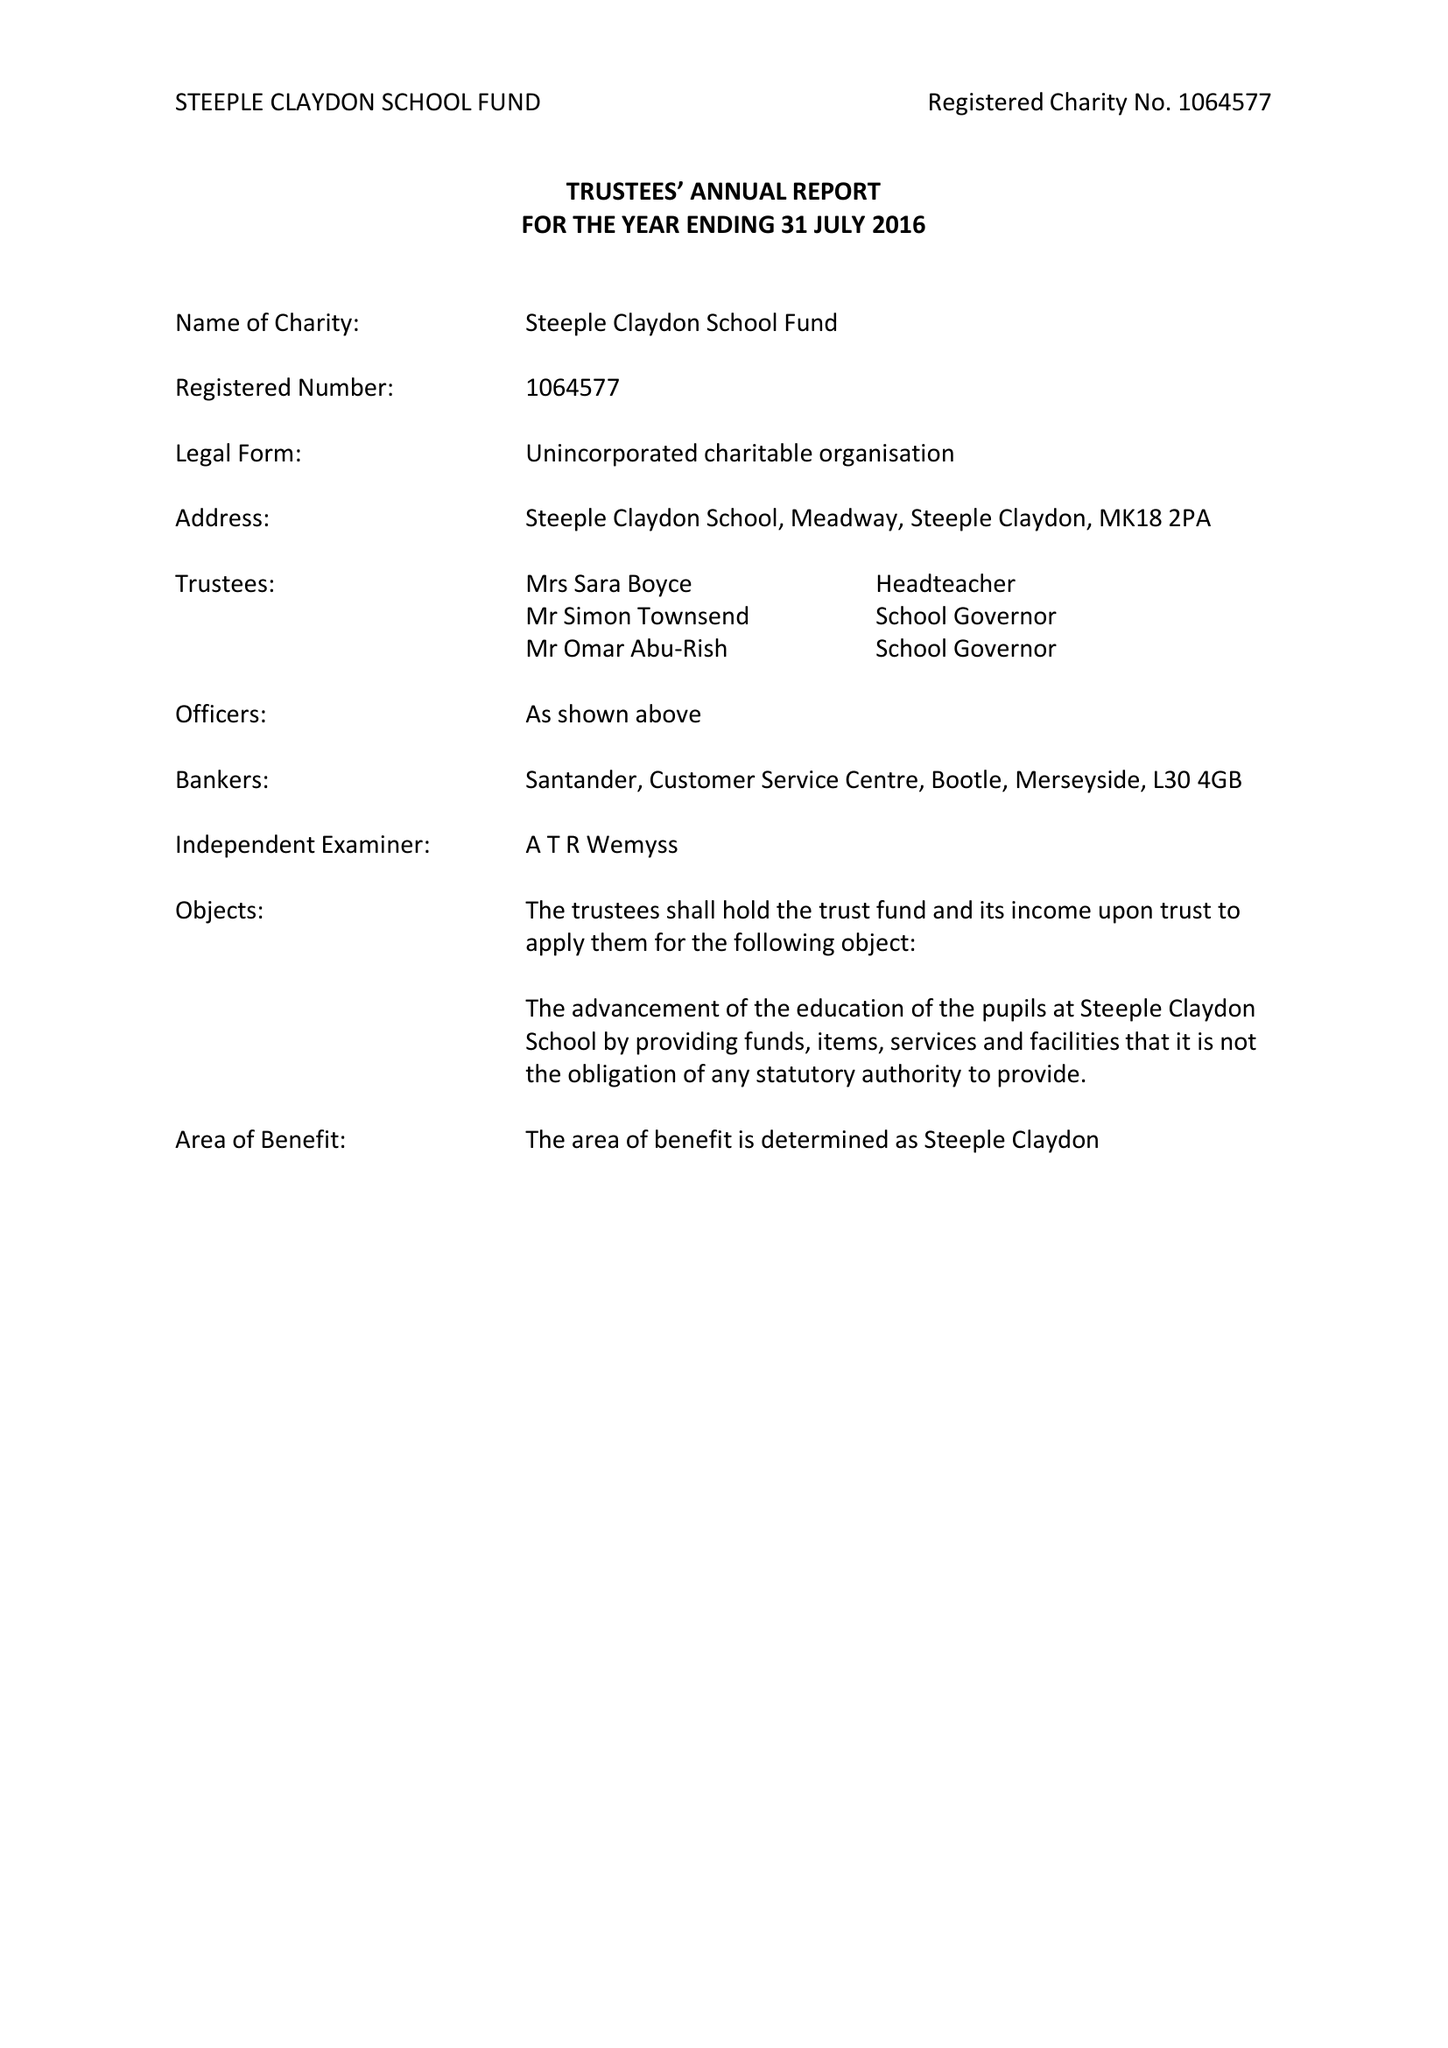What is the value for the charity_name?
Answer the question using a single word or phrase. Steeple Claydon School Fund 